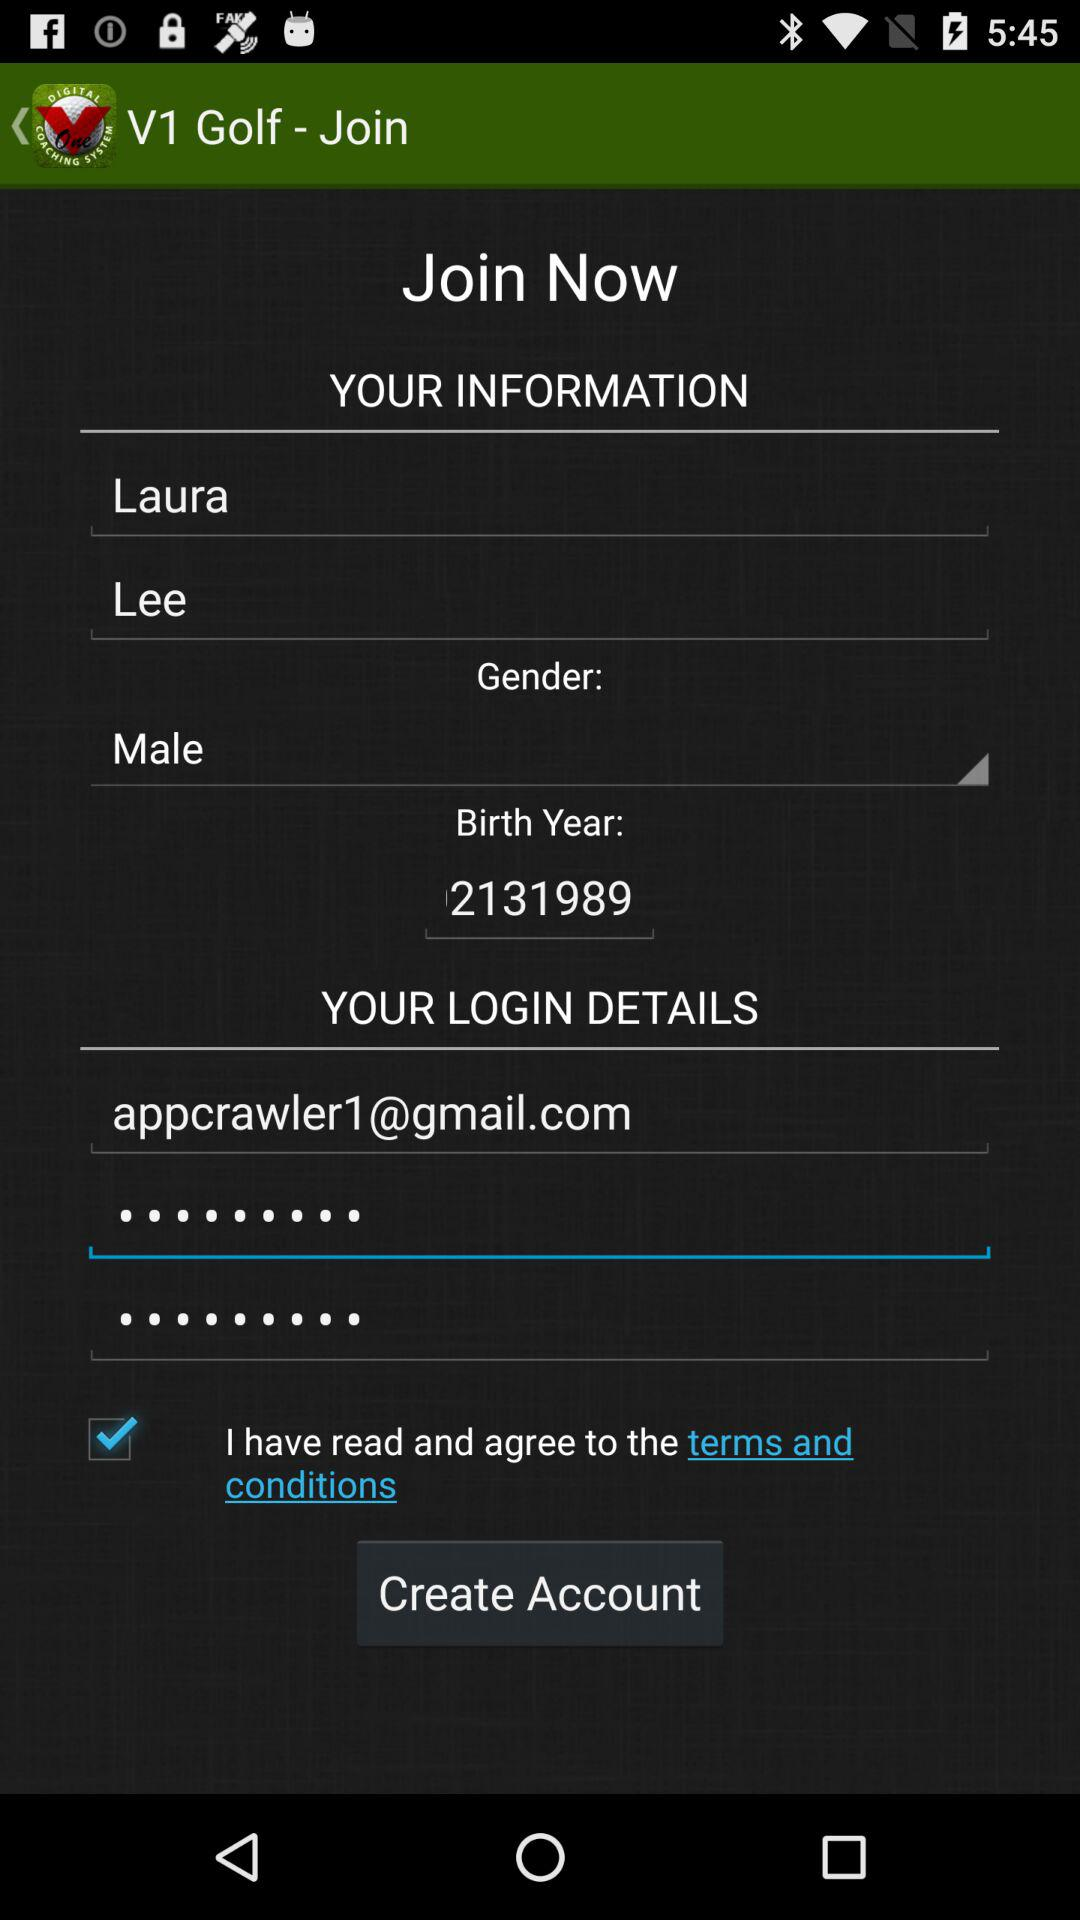What is the email address? The email address is appcrawler1@gmail.com. 